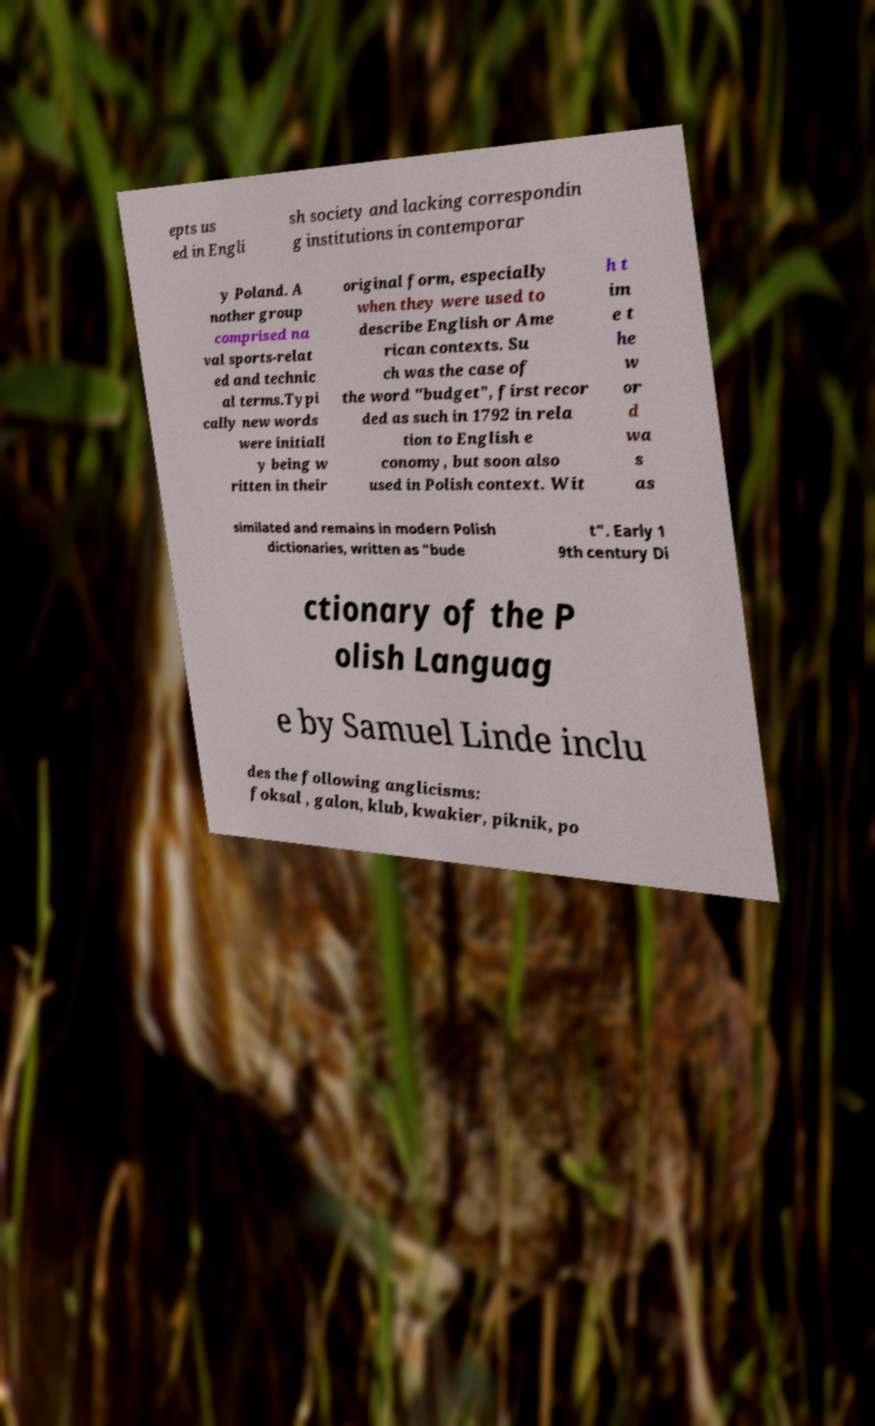Could you extract and type out the text from this image? epts us ed in Engli sh society and lacking correspondin g institutions in contemporar y Poland. A nother group comprised na val sports-relat ed and technic al terms.Typi cally new words were initiall y being w ritten in their original form, especially when they were used to describe English or Ame rican contexts. Su ch was the case of the word "budget", first recor ded as such in 1792 in rela tion to English e conomy, but soon also used in Polish context. Wit h t im e t he w or d wa s as similated and remains in modern Polish dictionaries, written as "bude t". Early 1 9th century Di ctionary of the P olish Languag e by Samuel Linde inclu des the following anglicisms: foksal , galon, klub, kwakier, piknik, po 